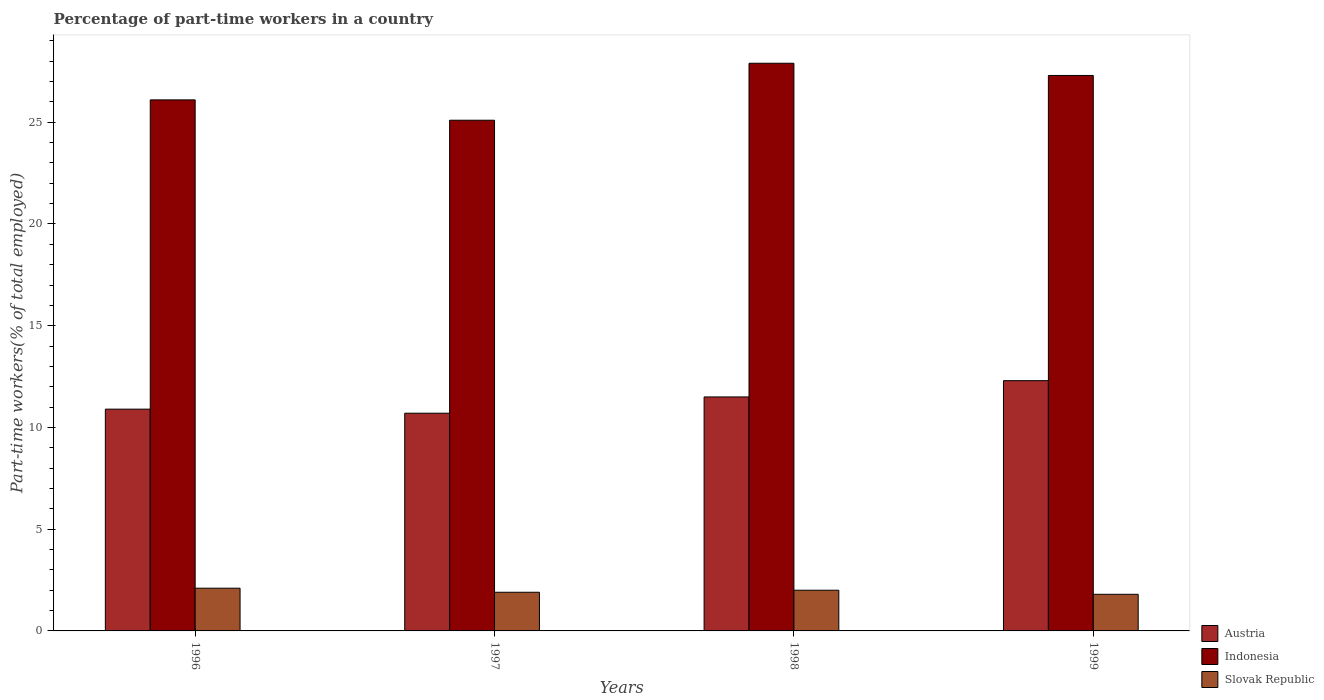Are the number of bars on each tick of the X-axis equal?
Your response must be concise. Yes. What is the label of the 3rd group of bars from the left?
Your answer should be very brief. 1998. In how many cases, is the number of bars for a given year not equal to the number of legend labels?
Give a very brief answer. 0. What is the percentage of part-time workers in Indonesia in 1996?
Keep it short and to the point. 26.1. Across all years, what is the maximum percentage of part-time workers in Indonesia?
Your answer should be very brief. 27.9. Across all years, what is the minimum percentage of part-time workers in Indonesia?
Keep it short and to the point. 25.1. In which year was the percentage of part-time workers in Slovak Republic maximum?
Ensure brevity in your answer.  1996. What is the total percentage of part-time workers in Austria in the graph?
Make the answer very short. 45.4. What is the difference between the percentage of part-time workers in Indonesia in 1996 and that in 1998?
Provide a succinct answer. -1.8. What is the difference between the percentage of part-time workers in Slovak Republic in 1998 and the percentage of part-time workers in Indonesia in 1999?
Keep it short and to the point. -25.3. What is the average percentage of part-time workers in Slovak Republic per year?
Provide a short and direct response. 1.95. In the year 1998, what is the difference between the percentage of part-time workers in Indonesia and percentage of part-time workers in Slovak Republic?
Offer a terse response. 25.9. In how many years, is the percentage of part-time workers in Slovak Republic greater than 22 %?
Ensure brevity in your answer.  0. What is the ratio of the percentage of part-time workers in Indonesia in 1996 to that in 1999?
Keep it short and to the point. 0.96. Is the percentage of part-time workers in Slovak Republic in 1996 less than that in 1999?
Your answer should be very brief. No. Is the difference between the percentage of part-time workers in Indonesia in 1998 and 1999 greater than the difference between the percentage of part-time workers in Slovak Republic in 1998 and 1999?
Your response must be concise. Yes. What is the difference between the highest and the second highest percentage of part-time workers in Indonesia?
Provide a short and direct response. 0.6. What is the difference between the highest and the lowest percentage of part-time workers in Indonesia?
Your answer should be very brief. 2.8. In how many years, is the percentage of part-time workers in Slovak Republic greater than the average percentage of part-time workers in Slovak Republic taken over all years?
Ensure brevity in your answer.  2. Is the sum of the percentage of part-time workers in Slovak Republic in 1998 and 1999 greater than the maximum percentage of part-time workers in Indonesia across all years?
Provide a succinct answer. No. What does the 1st bar from the right in 1997 represents?
Your answer should be compact. Slovak Republic. Is it the case that in every year, the sum of the percentage of part-time workers in Austria and percentage of part-time workers in Indonesia is greater than the percentage of part-time workers in Slovak Republic?
Offer a very short reply. Yes. How many bars are there?
Offer a very short reply. 12. Are all the bars in the graph horizontal?
Ensure brevity in your answer.  No. How many years are there in the graph?
Provide a short and direct response. 4. What is the difference between two consecutive major ticks on the Y-axis?
Provide a short and direct response. 5. Are the values on the major ticks of Y-axis written in scientific E-notation?
Ensure brevity in your answer.  No. Does the graph contain any zero values?
Make the answer very short. No. Does the graph contain grids?
Provide a succinct answer. No. What is the title of the graph?
Keep it short and to the point. Percentage of part-time workers in a country. Does "High income: nonOECD" appear as one of the legend labels in the graph?
Your answer should be compact. No. What is the label or title of the X-axis?
Make the answer very short. Years. What is the label or title of the Y-axis?
Give a very brief answer. Part-time workers(% of total employed). What is the Part-time workers(% of total employed) in Austria in 1996?
Offer a terse response. 10.9. What is the Part-time workers(% of total employed) in Indonesia in 1996?
Your response must be concise. 26.1. What is the Part-time workers(% of total employed) of Slovak Republic in 1996?
Offer a terse response. 2.1. What is the Part-time workers(% of total employed) in Austria in 1997?
Your answer should be very brief. 10.7. What is the Part-time workers(% of total employed) in Indonesia in 1997?
Keep it short and to the point. 25.1. What is the Part-time workers(% of total employed) in Slovak Republic in 1997?
Make the answer very short. 1.9. What is the Part-time workers(% of total employed) of Austria in 1998?
Your answer should be very brief. 11.5. What is the Part-time workers(% of total employed) in Indonesia in 1998?
Provide a succinct answer. 27.9. What is the Part-time workers(% of total employed) of Austria in 1999?
Make the answer very short. 12.3. What is the Part-time workers(% of total employed) in Indonesia in 1999?
Provide a succinct answer. 27.3. What is the Part-time workers(% of total employed) in Slovak Republic in 1999?
Your response must be concise. 1.8. Across all years, what is the maximum Part-time workers(% of total employed) of Austria?
Your answer should be compact. 12.3. Across all years, what is the maximum Part-time workers(% of total employed) of Indonesia?
Ensure brevity in your answer.  27.9. Across all years, what is the maximum Part-time workers(% of total employed) in Slovak Republic?
Your answer should be compact. 2.1. Across all years, what is the minimum Part-time workers(% of total employed) of Austria?
Your answer should be very brief. 10.7. Across all years, what is the minimum Part-time workers(% of total employed) in Indonesia?
Your answer should be very brief. 25.1. Across all years, what is the minimum Part-time workers(% of total employed) of Slovak Republic?
Your response must be concise. 1.8. What is the total Part-time workers(% of total employed) in Austria in the graph?
Your response must be concise. 45.4. What is the total Part-time workers(% of total employed) of Indonesia in the graph?
Your answer should be compact. 106.4. What is the difference between the Part-time workers(% of total employed) of Austria in 1996 and that in 1997?
Offer a very short reply. 0.2. What is the difference between the Part-time workers(% of total employed) of Austria in 1996 and that in 1998?
Provide a short and direct response. -0.6. What is the difference between the Part-time workers(% of total employed) of Indonesia in 1996 and that in 1998?
Offer a very short reply. -1.8. What is the difference between the Part-time workers(% of total employed) in Slovak Republic in 1996 and that in 1998?
Offer a very short reply. 0.1. What is the difference between the Part-time workers(% of total employed) in Slovak Republic in 1996 and that in 1999?
Offer a very short reply. 0.3. What is the difference between the Part-time workers(% of total employed) of Indonesia in 1997 and that in 1999?
Your answer should be very brief. -2.2. What is the difference between the Part-time workers(% of total employed) in Austria in 1998 and that in 1999?
Your response must be concise. -0.8. What is the difference between the Part-time workers(% of total employed) in Austria in 1996 and the Part-time workers(% of total employed) in Slovak Republic in 1997?
Offer a very short reply. 9. What is the difference between the Part-time workers(% of total employed) of Indonesia in 1996 and the Part-time workers(% of total employed) of Slovak Republic in 1997?
Keep it short and to the point. 24.2. What is the difference between the Part-time workers(% of total employed) of Austria in 1996 and the Part-time workers(% of total employed) of Indonesia in 1998?
Make the answer very short. -17. What is the difference between the Part-time workers(% of total employed) in Indonesia in 1996 and the Part-time workers(% of total employed) in Slovak Republic in 1998?
Provide a short and direct response. 24.1. What is the difference between the Part-time workers(% of total employed) in Austria in 1996 and the Part-time workers(% of total employed) in Indonesia in 1999?
Keep it short and to the point. -16.4. What is the difference between the Part-time workers(% of total employed) of Indonesia in 1996 and the Part-time workers(% of total employed) of Slovak Republic in 1999?
Your response must be concise. 24.3. What is the difference between the Part-time workers(% of total employed) of Austria in 1997 and the Part-time workers(% of total employed) of Indonesia in 1998?
Provide a succinct answer. -17.2. What is the difference between the Part-time workers(% of total employed) in Austria in 1997 and the Part-time workers(% of total employed) in Slovak Republic in 1998?
Ensure brevity in your answer.  8.7. What is the difference between the Part-time workers(% of total employed) in Indonesia in 1997 and the Part-time workers(% of total employed) in Slovak Republic in 1998?
Provide a short and direct response. 23.1. What is the difference between the Part-time workers(% of total employed) in Austria in 1997 and the Part-time workers(% of total employed) in Indonesia in 1999?
Your response must be concise. -16.6. What is the difference between the Part-time workers(% of total employed) in Indonesia in 1997 and the Part-time workers(% of total employed) in Slovak Republic in 1999?
Your response must be concise. 23.3. What is the difference between the Part-time workers(% of total employed) of Austria in 1998 and the Part-time workers(% of total employed) of Indonesia in 1999?
Your answer should be compact. -15.8. What is the difference between the Part-time workers(% of total employed) in Indonesia in 1998 and the Part-time workers(% of total employed) in Slovak Republic in 1999?
Your response must be concise. 26.1. What is the average Part-time workers(% of total employed) in Austria per year?
Your response must be concise. 11.35. What is the average Part-time workers(% of total employed) of Indonesia per year?
Provide a succinct answer. 26.6. What is the average Part-time workers(% of total employed) of Slovak Republic per year?
Provide a succinct answer. 1.95. In the year 1996, what is the difference between the Part-time workers(% of total employed) in Austria and Part-time workers(% of total employed) in Indonesia?
Provide a short and direct response. -15.2. In the year 1997, what is the difference between the Part-time workers(% of total employed) in Austria and Part-time workers(% of total employed) in Indonesia?
Ensure brevity in your answer.  -14.4. In the year 1997, what is the difference between the Part-time workers(% of total employed) in Austria and Part-time workers(% of total employed) in Slovak Republic?
Ensure brevity in your answer.  8.8. In the year 1997, what is the difference between the Part-time workers(% of total employed) in Indonesia and Part-time workers(% of total employed) in Slovak Republic?
Your answer should be compact. 23.2. In the year 1998, what is the difference between the Part-time workers(% of total employed) in Austria and Part-time workers(% of total employed) in Indonesia?
Make the answer very short. -16.4. In the year 1998, what is the difference between the Part-time workers(% of total employed) in Indonesia and Part-time workers(% of total employed) in Slovak Republic?
Ensure brevity in your answer.  25.9. In the year 1999, what is the difference between the Part-time workers(% of total employed) in Austria and Part-time workers(% of total employed) in Indonesia?
Ensure brevity in your answer.  -15. In the year 1999, what is the difference between the Part-time workers(% of total employed) in Austria and Part-time workers(% of total employed) in Slovak Republic?
Ensure brevity in your answer.  10.5. In the year 1999, what is the difference between the Part-time workers(% of total employed) of Indonesia and Part-time workers(% of total employed) of Slovak Republic?
Offer a very short reply. 25.5. What is the ratio of the Part-time workers(% of total employed) in Austria in 1996 to that in 1997?
Give a very brief answer. 1.02. What is the ratio of the Part-time workers(% of total employed) of Indonesia in 1996 to that in 1997?
Your answer should be very brief. 1.04. What is the ratio of the Part-time workers(% of total employed) in Slovak Republic in 1996 to that in 1997?
Ensure brevity in your answer.  1.11. What is the ratio of the Part-time workers(% of total employed) in Austria in 1996 to that in 1998?
Keep it short and to the point. 0.95. What is the ratio of the Part-time workers(% of total employed) of Indonesia in 1996 to that in 1998?
Make the answer very short. 0.94. What is the ratio of the Part-time workers(% of total employed) in Austria in 1996 to that in 1999?
Your response must be concise. 0.89. What is the ratio of the Part-time workers(% of total employed) in Indonesia in 1996 to that in 1999?
Your answer should be compact. 0.96. What is the ratio of the Part-time workers(% of total employed) in Austria in 1997 to that in 1998?
Offer a very short reply. 0.93. What is the ratio of the Part-time workers(% of total employed) in Indonesia in 1997 to that in 1998?
Make the answer very short. 0.9. What is the ratio of the Part-time workers(% of total employed) of Slovak Republic in 1997 to that in 1998?
Give a very brief answer. 0.95. What is the ratio of the Part-time workers(% of total employed) in Austria in 1997 to that in 1999?
Make the answer very short. 0.87. What is the ratio of the Part-time workers(% of total employed) of Indonesia in 1997 to that in 1999?
Give a very brief answer. 0.92. What is the ratio of the Part-time workers(% of total employed) of Slovak Republic in 1997 to that in 1999?
Give a very brief answer. 1.06. What is the ratio of the Part-time workers(% of total employed) in Austria in 1998 to that in 1999?
Offer a very short reply. 0.94. What is the ratio of the Part-time workers(% of total employed) in Indonesia in 1998 to that in 1999?
Offer a very short reply. 1.02. What is the ratio of the Part-time workers(% of total employed) of Slovak Republic in 1998 to that in 1999?
Offer a very short reply. 1.11. What is the difference between the highest and the lowest Part-time workers(% of total employed) of Indonesia?
Offer a terse response. 2.8. What is the difference between the highest and the lowest Part-time workers(% of total employed) in Slovak Republic?
Make the answer very short. 0.3. 